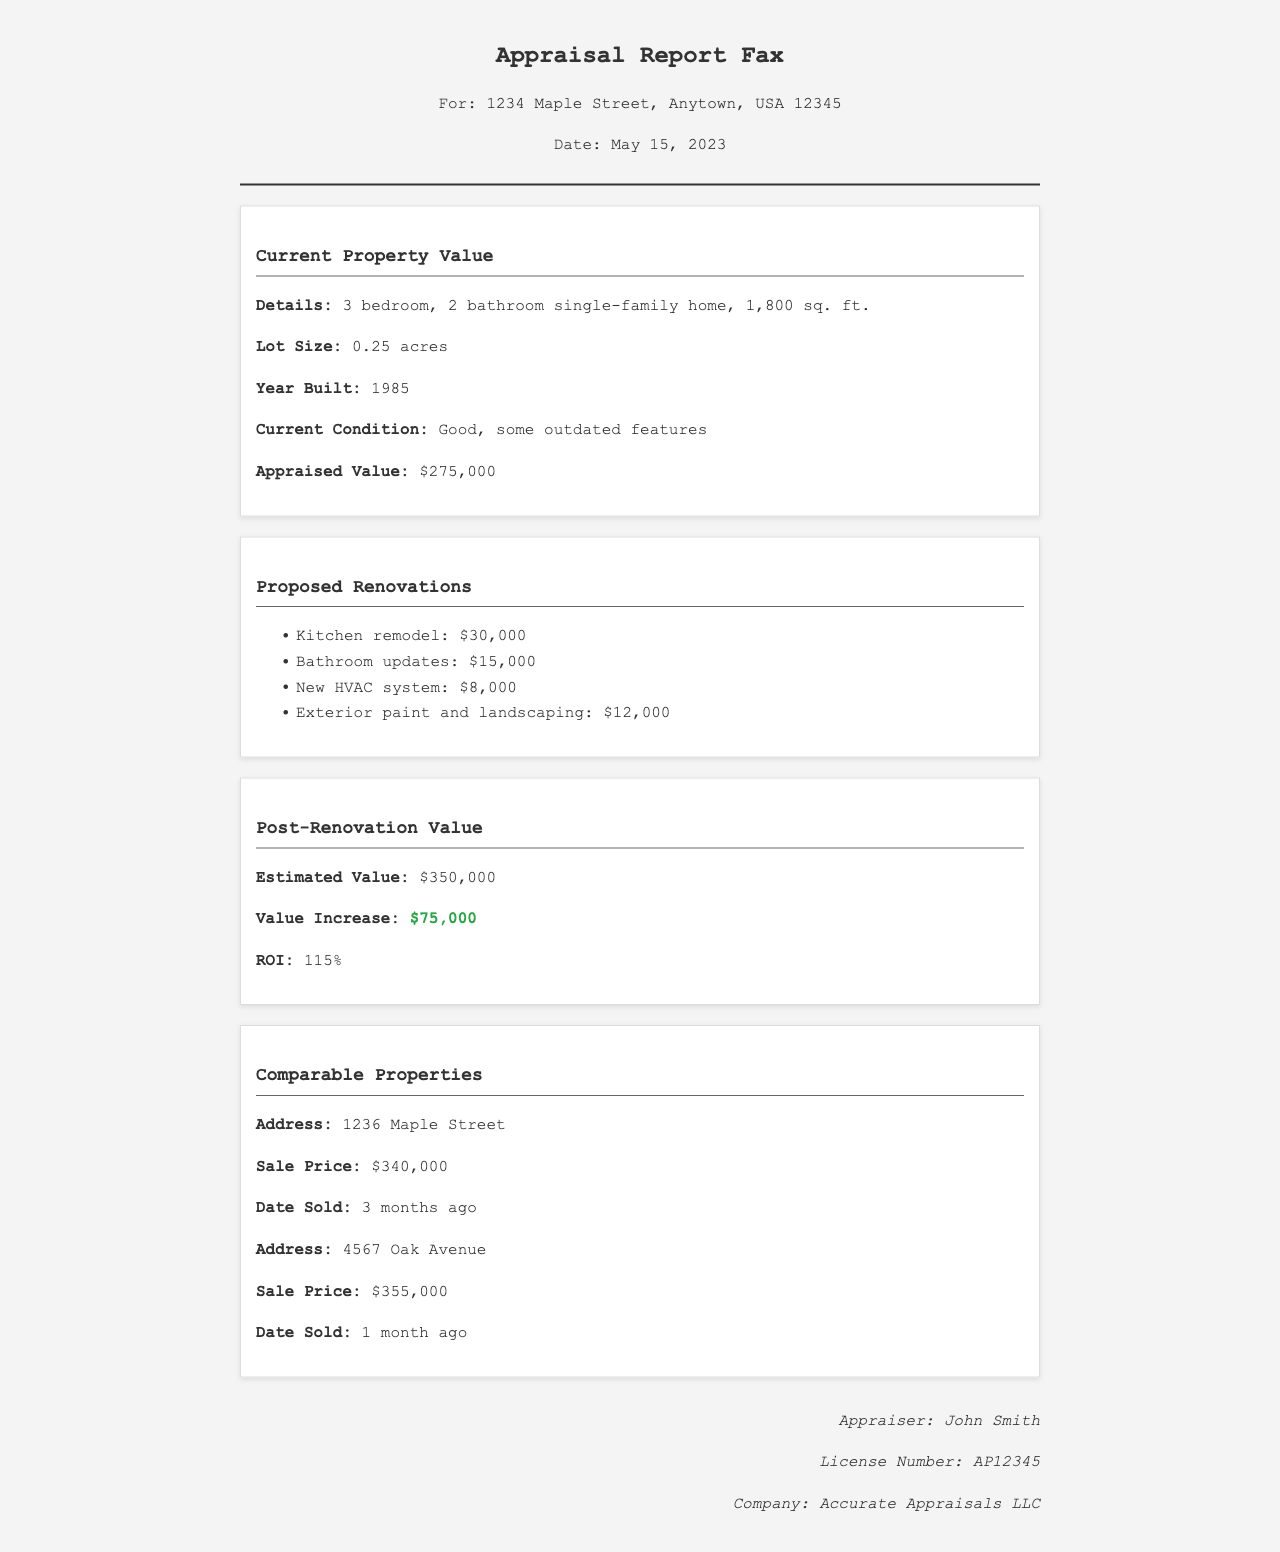What is the appraised value of the property? The appraised value is stated clearly in the document under "Appraised Value."
Answer: $275,000 What is the proposed budget for the kitchen remodel? The proposed budget for the kitchen remodel is listed in the "Proposed Renovations" section of the document.
Answer: $30,000 What is the estimated post-renovation value? The estimated post-renovation value is provided under "Post-Renovation Value."
Answer: $350,000 How much is the total value increase after renovations? The value increase is mentioned in the "Post-Renovation Value" section as the difference between current and post-renovation value.
Answer: $75,000 Who is the appraiser for this report? The appraiser's name is found at the bottom of the document in the appraiser info section.
Answer: John Smith What is the return on investment (ROI) from the renovations? The ROI percentage is listed in the "Post-Renovation Value" section.
Answer: 115% What is the condition of the property before renovations? The property's condition is described in the "Current Condition" line within the "Current Property Value" section.
Answer: Good, some outdated features How many bedrooms does the property have? The number of bedrooms is mentioned in the description of the property in the "Current Property Value" section.
Answer: 3 bedrooms When was the appraisal report faxed? The date of the appraisal report fax is noted in the header section of the document.
Answer: May 15, 2023 